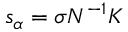<formula> <loc_0><loc_0><loc_500><loc_500>s _ { \alpha } = \sigma N ^ { - 1 } K</formula> 